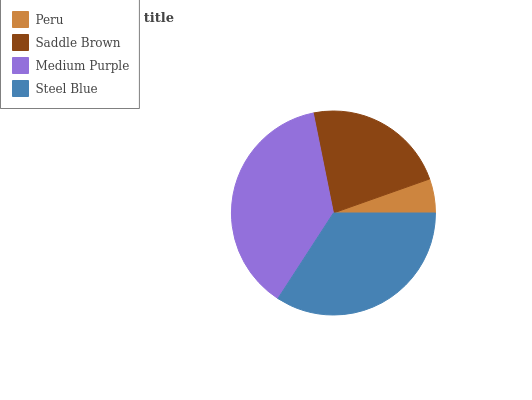Is Peru the minimum?
Answer yes or no. Yes. Is Medium Purple the maximum?
Answer yes or no. Yes. Is Saddle Brown the minimum?
Answer yes or no. No. Is Saddle Brown the maximum?
Answer yes or no. No. Is Saddle Brown greater than Peru?
Answer yes or no. Yes. Is Peru less than Saddle Brown?
Answer yes or no. Yes. Is Peru greater than Saddle Brown?
Answer yes or no. No. Is Saddle Brown less than Peru?
Answer yes or no. No. Is Steel Blue the high median?
Answer yes or no. Yes. Is Saddle Brown the low median?
Answer yes or no. Yes. Is Saddle Brown the high median?
Answer yes or no. No. Is Peru the low median?
Answer yes or no. No. 